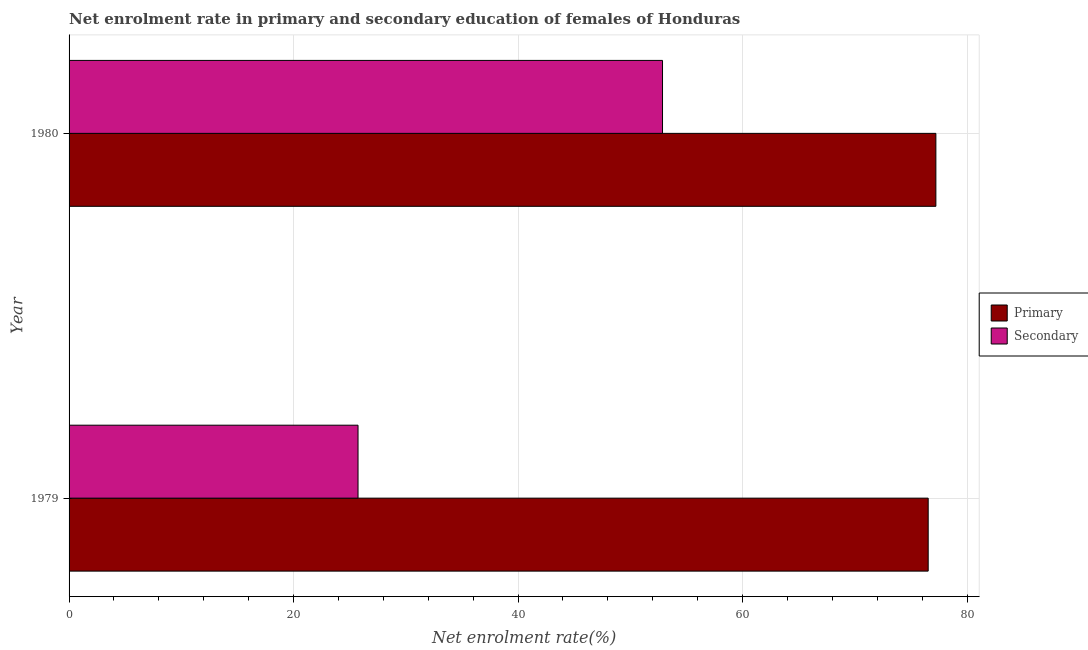How many different coloured bars are there?
Provide a succinct answer. 2. How many groups of bars are there?
Make the answer very short. 2. Are the number of bars per tick equal to the number of legend labels?
Offer a terse response. Yes. How many bars are there on the 2nd tick from the top?
Offer a terse response. 2. What is the label of the 2nd group of bars from the top?
Provide a short and direct response. 1979. In how many cases, is the number of bars for a given year not equal to the number of legend labels?
Your answer should be compact. 0. What is the enrollment rate in primary education in 1980?
Offer a very short reply. 77.22. Across all years, what is the maximum enrollment rate in primary education?
Your response must be concise. 77.22. Across all years, what is the minimum enrollment rate in secondary education?
Give a very brief answer. 25.74. In which year was the enrollment rate in secondary education minimum?
Provide a succinct answer. 1979. What is the total enrollment rate in secondary education in the graph?
Provide a succinct answer. 78.61. What is the difference between the enrollment rate in secondary education in 1979 and that in 1980?
Offer a terse response. -27.13. What is the difference between the enrollment rate in secondary education in 1979 and the enrollment rate in primary education in 1980?
Provide a short and direct response. -51.48. What is the average enrollment rate in primary education per year?
Your answer should be compact. 76.88. In the year 1980, what is the difference between the enrollment rate in secondary education and enrollment rate in primary education?
Provide a short and direct response. -24.35. In how many years, is the enrollment rate in primary education greater than 32 %?
Offer a terse response. 2. What is the ratio of the enrollment rate in secondary education in 1979 to that in 1980?
Provide a short and direct response. 0.49. Is the difference between the enrollment rate in primary education in 1979 and 1980 greater than the difference between the enrollment rate in secondary education in 1979 and 1980?
Provide a short and direct response. Yes. What does the 1st bar from the top in 1980 represents?
Provide a short and direct response. Secondary. What does the 2nd bar from the bottom in 1979 represents?
Your response must be concise. Secondary. Are all the bars in the graph horizontal?
Ensure brevity in your answer.  Yes. Are the values on the major ticks of X-axis written in scientific E-notation?
Offer a terse response. No. Does the graph contain grids?
Offer a terse response. Yes. How are the legend labels stacked?
Your response must be concise. Vertical. What is the title of the graph?
Your answer should be compact. Net enrolment rate in primary and secondary education of females of Honduras. What is the label or title of the X-axis?
Offer a terse response. Net enrolment rate(%). What is the label or title of the Y-axis?
Provide a short and direct response. Year. What is the Net enrolment rate(%) of Primary in 1979?
Make the answer very short. 76.54. What is the Net enrolment rate(%) of Secondary in 1979?
Give a very brief answer. 25.74. What is the Net enrolment rate(%) in Primary in 1980?
Provide a succinct answer. 77.22. What is the Net enrolment rate(%) of Secondary in 1980?
Make the answer very short. 52.87. Across all years, what is the maximum Net enrolment rate(%) in Primary?
Make the answer very short. 77.22. Across all years, what is the maximum Net enrolment rate(%) in Secondary?
Provide a short and direct response. 52.87. Across all years, what is the minimum Net enrolment rate(%) in Primary?
Make the answer very short. 76.54. Across all years, what is the minimum Net enrolment rate(%) in Secondary?
Your response must be concise. 25.74. What is the total Net enrolment rate(%) in Primary in the graph?
Your answer should be very brief. 153.76. What is the total Net enrolment rate(%) in Secondary in the graph?
Provide a succinct answer. 78.61. What is the difference between the Net enrolment rate(%) in Primary in 1979 and that in 1980?
Provide a short and direct response. -0.68. What is the difference between the Net enrolment rate(%) of Secondary in 1979 and that in 1980?
Offer a terse response. -27.13. What is the difference between the Net enrolment rate(%) in Primary in 1979 and the Net enrolment rate(%) in Secondary in 1980?
Your response must be concise. 23.67. What is the average Net enrolment rate(%) in Primary per year?
Keep it short and to the point. 76.88. What is the average Net enrolment rate(%) in Secondary per year?
Your answer should be compact. 39.31. In the year 1979, what is the difference between the Net enrolment rate(%) in Primary and Net enrolment rate(%) in Secondary?
Your answer should be compact. 50.8. In the year 1980, what is the difference between the Net enrolment rate(%) in Primary and Net enrolment rate(%) in Secondary?
Give a very brief answer. 24.35. What is the ratio of the Net enrolment rate(%) of Secondary in 1979 to that in 1980?
Offer a terse response. 0.49. What is the difference between the highest and the second highest Net enrolment rate(%) of Primary?
Your answer should be compact. 0.68. What is the difference between the highest and the second highest Net enrolment rate(%) in Secondary?
Provide a succinct answer. 27.13. What is the difference between the highest and the lowest Net enrolment rate(%) in Primary?
Make the answer very short. 0.68. What is the difference between the highest and the lowest Net enrolment rate(%) in Secondary?
Offer a very short reply. 27.13. 